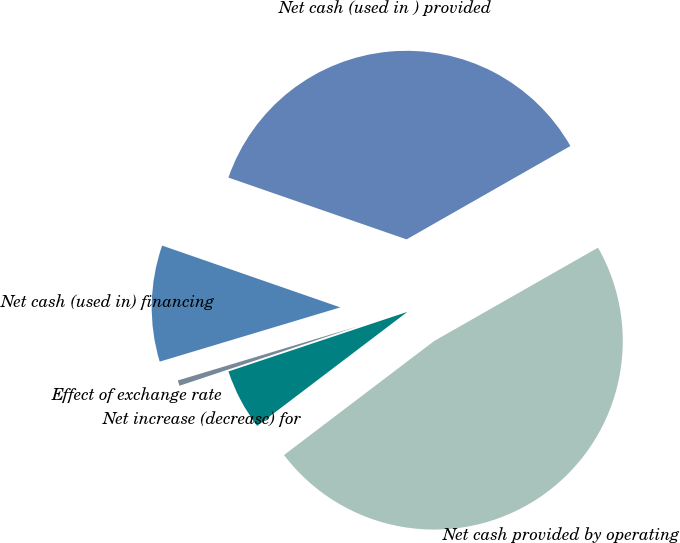Convert chart to OTSL. <chart><loc_0><loc_0><loc_500><loc_500><pie_chart><fcel>Net cash provided by operating<fcel>Net cash (used in ) provided<fcel>Net cash (used in) financing<fcel>Effect of exchange rate<fcel>Net increase (decrease) for<nl><fcel>47.91%<fcel>36.44%<fcel>9.96%<fcel>0.47%<fcel>5.22%<nl></chart> 